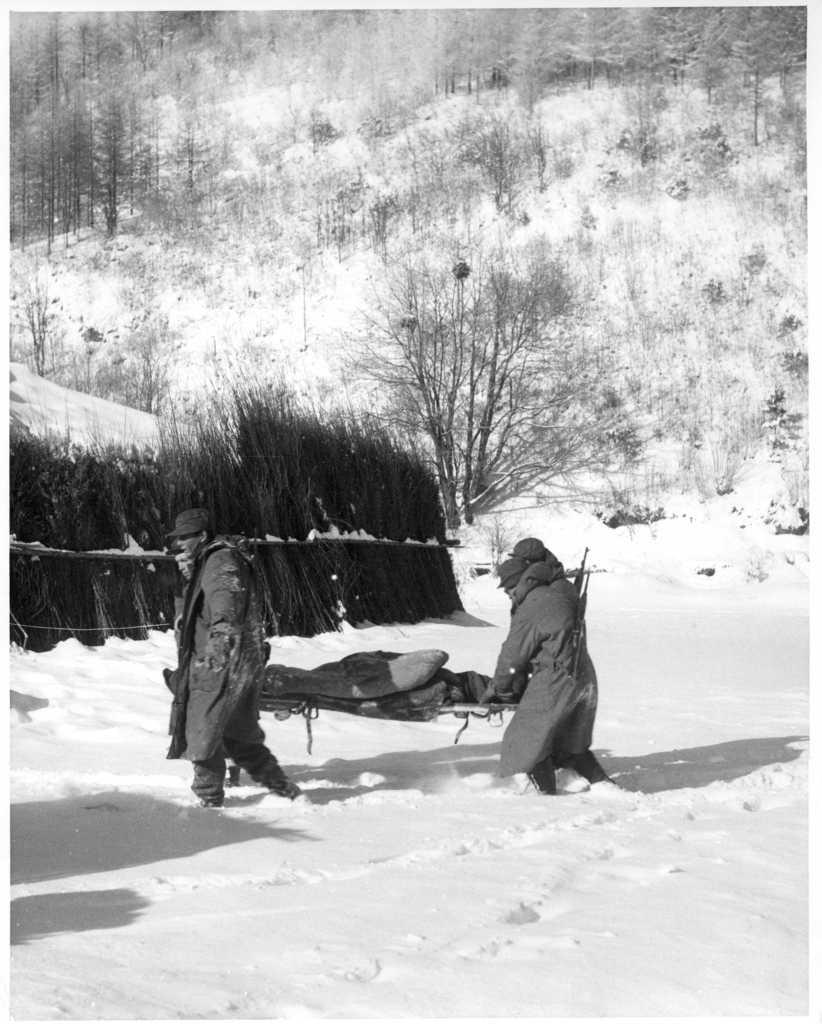How many people are in the image? There is a group of people in the image. What are some of the people in the image doing? Some people are walking on the snow. What can be seen in the background of the image? There are trees in the background of the image. What is the color scheme of the image? The photography is in black and white. Can you see any goldfish swimming in the snow in the image? There are no goldfish present in the image, as it features a group of people walking on the snow and trees in the background. 